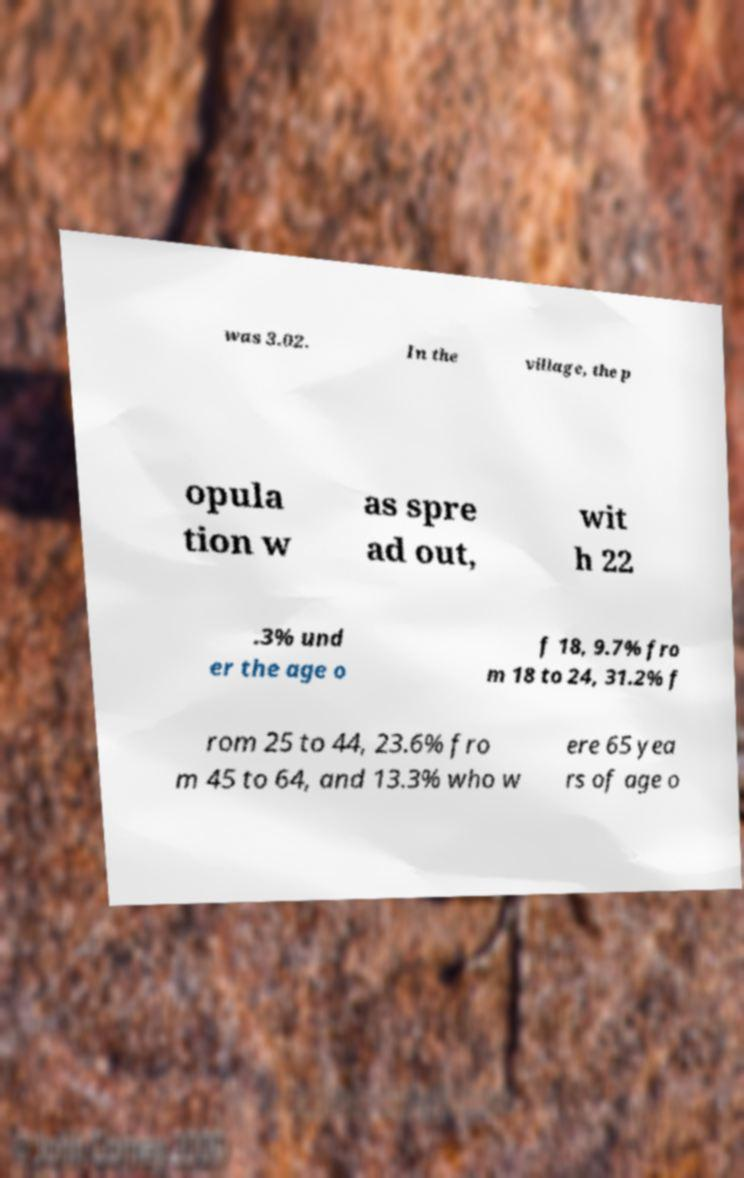I need the written content from this picture converted into text. Can you do that? was 3.02. In the village, the p opula tion w as spre ad out, wit h 22 .3% und er the age o f 18, 9.7% fro m 18 to 24, 31.2% f rom 25 to 44, 23.6% fro m 45 to 64, and 13.3% who w ere 65 yea rs of age o 